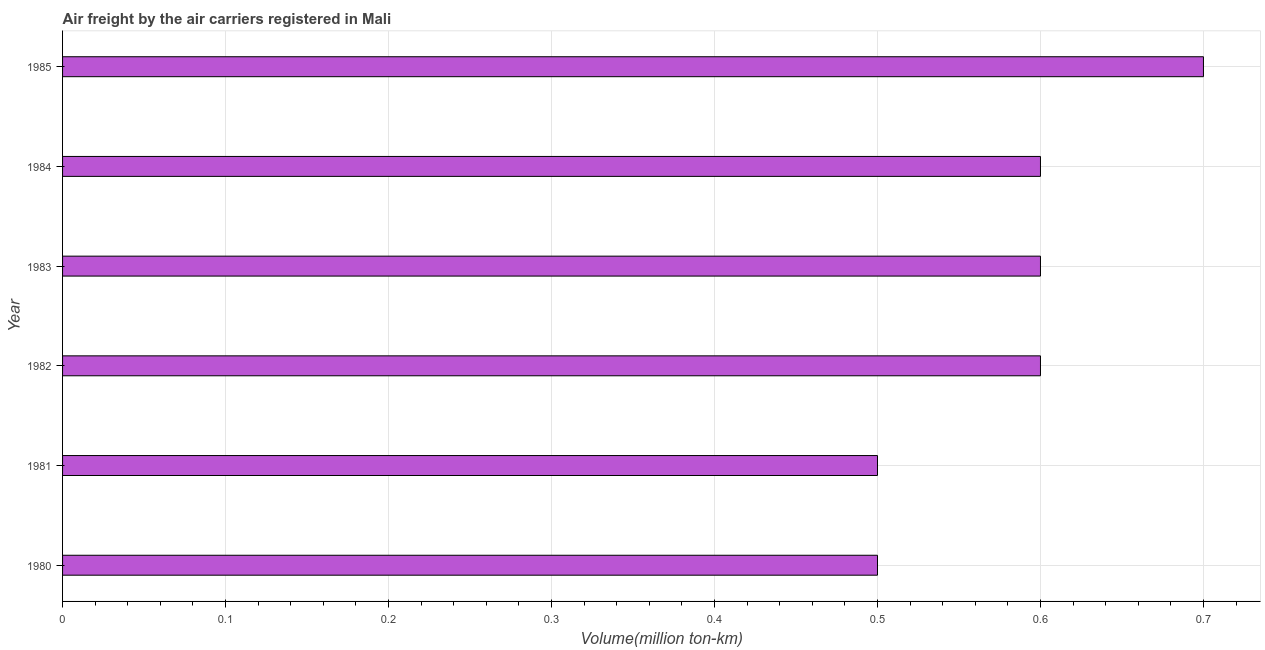Does the graph contain any zero values?
Your response must be concise. No. Does the graph contain grids?
Provide a short and direct response. Yes. What is the title of the graph?
Make the answer very short. Air freight by the air carriers registered in Mali. What is the label or title of the X-axis?
Ensure brevity in your answer.  Volume(million ton-km). What is the air freight in 1984?
Ensure brevity in your answer.  0.6. Across all years, what is the maximum air freight?
Make the answer very short. 0.7. Across all years, what is the minimum air freight?
Provide a short and direct response. 0.5. In which year was the air freight maximum?
Offer a terse response. 1985. In which year was the air freight minimum?
Offer a very short reply. 1980. What is the sum of the air freight?
Your answer should be compact. 3.5. What is the difference between the air freight in 1982 and 1983?
Provide a short and direct response. 0. What is the average air freight per year?
Provide a succinct answer. 0.58. What is the median air freight?
Give a very brief answer. 0.6. In how many years, is the air freight greater than 0.24 million ton-km?
Ensure brevity in your answer.  6. What is the ratio of the air freight in 1982 to that in 1984?
Offer a terse response. 1. Is the difference between the air freight in 1980 and 1981 greater than the difference between any two years?
Your answer should be very brief. No. How many bars are there?
Offer a terse response. 6. Are all the bars in the graph horizontal?
Ensure brevity in your answer.  Yes. What is the difference between two consecutive major ticks on the X-axis?
Your response must be concise. 0.1. What is the Volume(million ton-km) in 1982?
Your answer should be very brief. 0.6. What is the Volume(million ton-km) in 1983?
Your answer should be very brief. 0.6. What is the Volume(million ton-km) of 1984?
Provide a succinct answer. 0.6. What is the Volume(million ton-km) of 1985?
Provide a succinct answer. 0.7. What is the difference between the Volume(million ton-km) in 1980 and 1982?
Provide a succinct answer. -0.1. What is the difference between the Volume(million ton-km) in 1981 and 1982?
Make the answer very short. -0.1. What is the difference between the Volume(million ton-km) in 1983 and 1984?
Make the answer very short. 0. What is the difference between the Volume(million ton-km) in 1983 and 1985?
Your response must be concise. -0.1. What is the difference between the Volume(million ton-km) in 1984 and 1985?
Offer a terse response. -0.1. What is the ratio of the Volume(million ton-km) in 1980 to that in 1982?
Give a very brief answer. 0.83. What is the ratio of the Volume(million ton-km) in 1980 to that in 1983?
Make the answer very short. 0.83. What is the ratio of the Volume(million ton-km) in 1980 to that in 1984?
Your answer should be compact. 0.83. What is the ratio of the Volume(million ton-km) in 1980 to that in 1985?
Keep it short and to the point. 0.71. What is the ratio of the Volume(million ton-km) in 1981 to that in 1982?
Your response must be concise. 0.83. What is the ratio of the Volume(million ton-km) in 1981 to that in 1983?
Provide a succinct answer. 0.83. What is the ratio of the Volume(million ton-km) in 1981 to that in 1984?
Keep it short and to the point. 0.83. What is the ratio of the Volume(million ton-km) in 1981 to that in 1985?
Ensure brevity in your answer.  0.71. What is the ratio of the Volume(million ton-km) in 1982 to that in 1983?
Provide a short and direct response. 1. What is the ratio of the Volume(million ton-km) in 1982 to that in 1984?
Give a very brief answer. 1. What is the ratio of the Volume(million ton-km) in 1982 to that in 1985?
Keep it short and to the point. 0.86. What is the ratio of the Volume(million ton-km) in 1983 to that in 1985?
Offer a terse response. 0.86. What is the ratio of the Volume(million ton-km) in 1984 to that in 1985?
Your response must be concise. 0.86. 